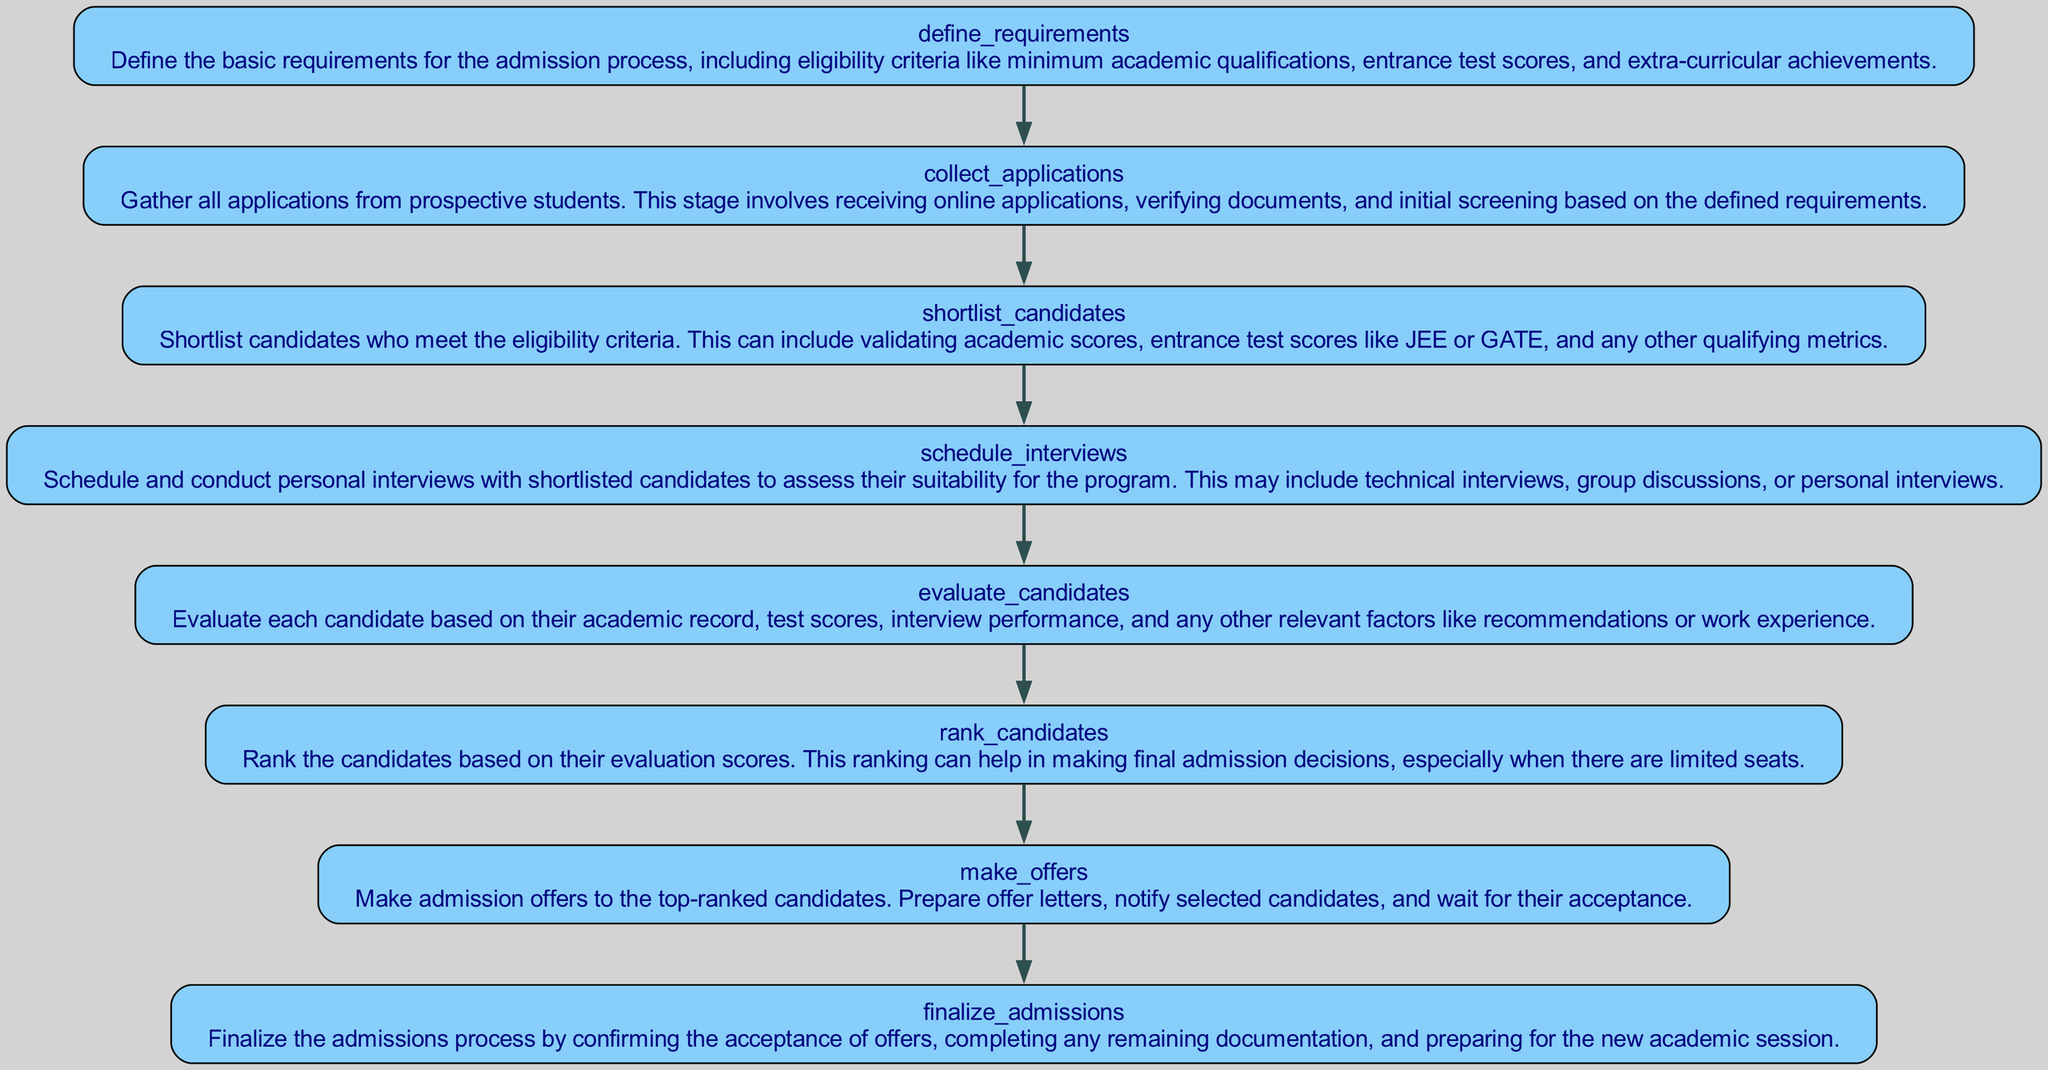What is the first step in the admission process? The first step listed in the diagram is "define_requirements," which outlines the eligibility criteria for the admission process.
Answer: define_requirements How many total steps are included in the admission process? The diagram includes a total of eight steps from defining requirements to finalizing admissions.
Answer: eight Which step follows "shortlist_candidates"? The step that follows "shortlist_candidates" is "schedule_interviews," indicating that after candidates are shortlisted, interviews will be scheduled.
Answer: schedule_interviews What is the last step in the admission process? The last step in the diagram is "finalize_admissions," which indicates the completion of the admissions process after offers are accepted.
Answer: finalize_admissions How are candidates evaluated? Candidates are evaluated in the "evaluate_candidates" step based on their academic record, test scores, and interview performance.
Answer: evaluate_candidates Which step involves making admission offers? The step that involves making admission offers is "make_offers," where offers are prepared and communicated to selected candidates.
Answer: make_offers What is the relationship between "collect_applications" and "shortlist_candidates"? "collect_applications" is the preceding step before "shortlist_candidates," indicating that applications must be gathered before candidates can be shortlisted.
Answer: collect_applications precedes shortlist_candidates How is the ranking of candidates determined? Candidates are ranked based on their evaluation scores in the "rank_candidates" step, which consolidates all assessment metrics.
Answer: evaluate scores What action occurs after candidates are ranked? After candidates are ranked, the next action is to "make_offers," which entails preparing admission offers for the top candidates.
Answer: make_offers 